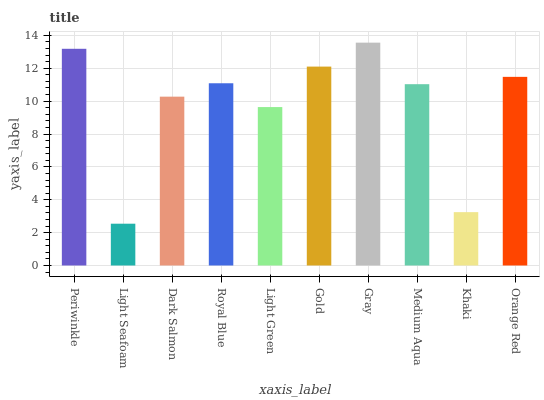Is Light Seafoam the minimum?
Answer yes or no. Yes. Is Gray the maximum?
Answer yes or no. Yes. Is Dark Salmon the minimum?
Answer yes or no. No. Is Dark Salmon the maximum?
Answer yes or no. No. Is Dark Salmon greater than Light Seafoam?
Answer yes or no. Yes. Is Light Seafoam less than Dark Salmon?
Answer yes or no. Yes. Is Light Seafoam greater than Dark Salmon?
Answer yes or no. No. Is Dark Salmon less than Light Seafoam?
Answer yes or no. No. Is Royal Blue the high median?
Answer yes or no. Yes. Is Medium Aqua the low median?
Answer yes or no. Yes. Is Gray the high median?
Answer yes or no. No. Is Light Green the low median?
Answer yes or no. No. 